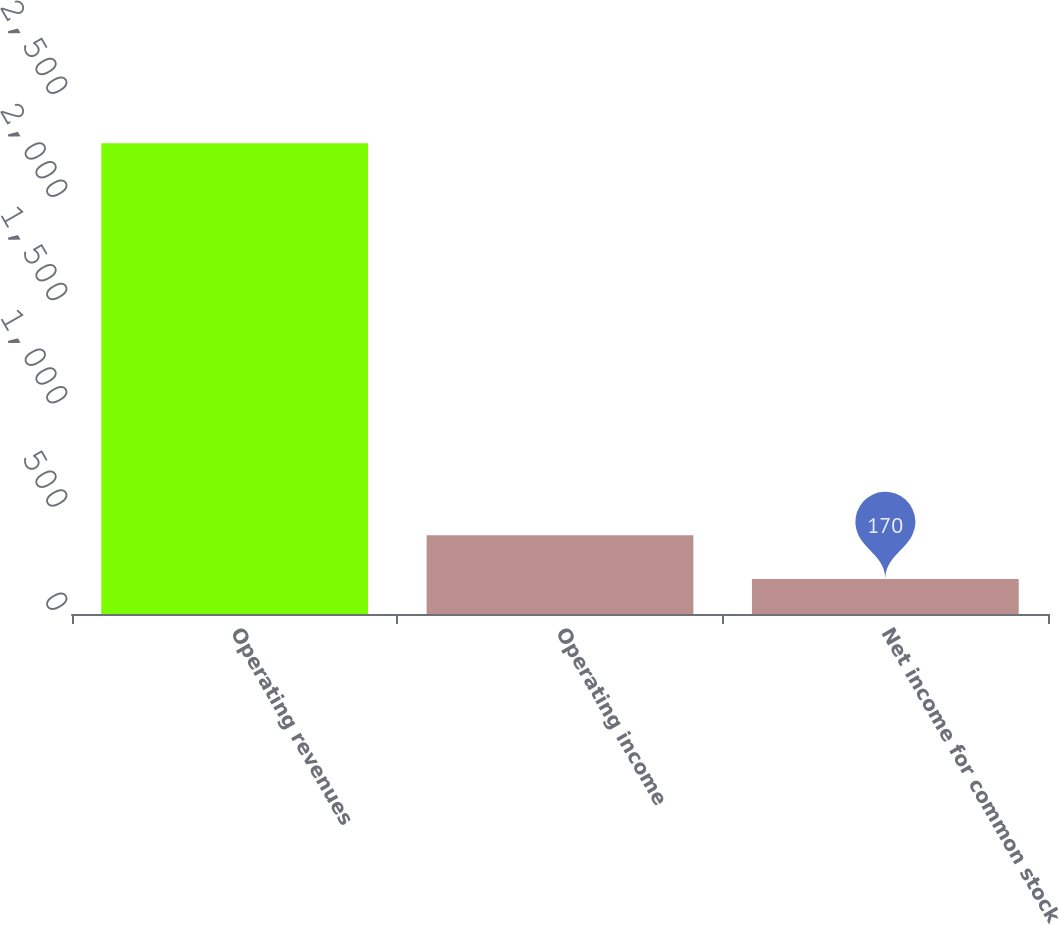Convert chart. <chart><loc_0><loc_0><loc_500><loc_500><bar_chart><fcel>Operating revenues<fcel>Operating income<fcel>Net income for common stock<nl><fcel>2281<fcel>381.1<fcel>170<nl></chart> 